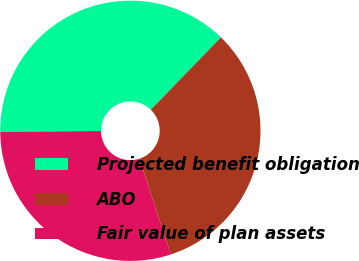<chart> <loc_0><loc_0><loc_500><loc_500><pie_chart><fcel>Projected benefit obligation<fcel>ABO<fcel>Fair value of plan assets<nl><fcel>37.38%<fcel>32.72%<fcel>29.9%<nl></chart> 